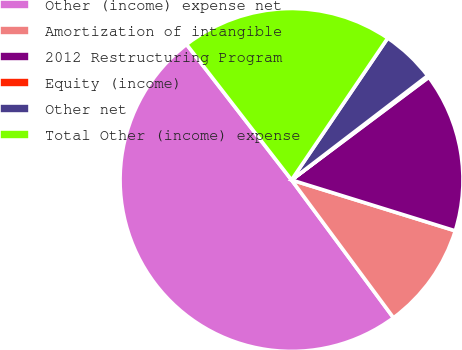Convert chart. <chart><loc_0><loc_0><loc_500><loc_500><pie_chart><fcel>Other (income) expense net<fcel>Amortization of intangible<fcel>2012 Restructuring Program<fcel>Equity (income)<fcel>Other net<fcel>Total Other (income) expense<nl><fcel>49.65%<fcel>10.07%<fcel>15.02%<fcel>0.17%<fcel>5.12%<fcel>19.97%<nl></chart> 